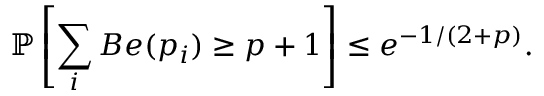<formula> <loc_0><loc_0><loc_500><loc_500>\mathbb { P } \left [ \sum _ { i } B e ( p _ { i } ) \geq p + 1 \right ] \leq e ^ { - 1 / ( 2 + p ) } .</formula> 